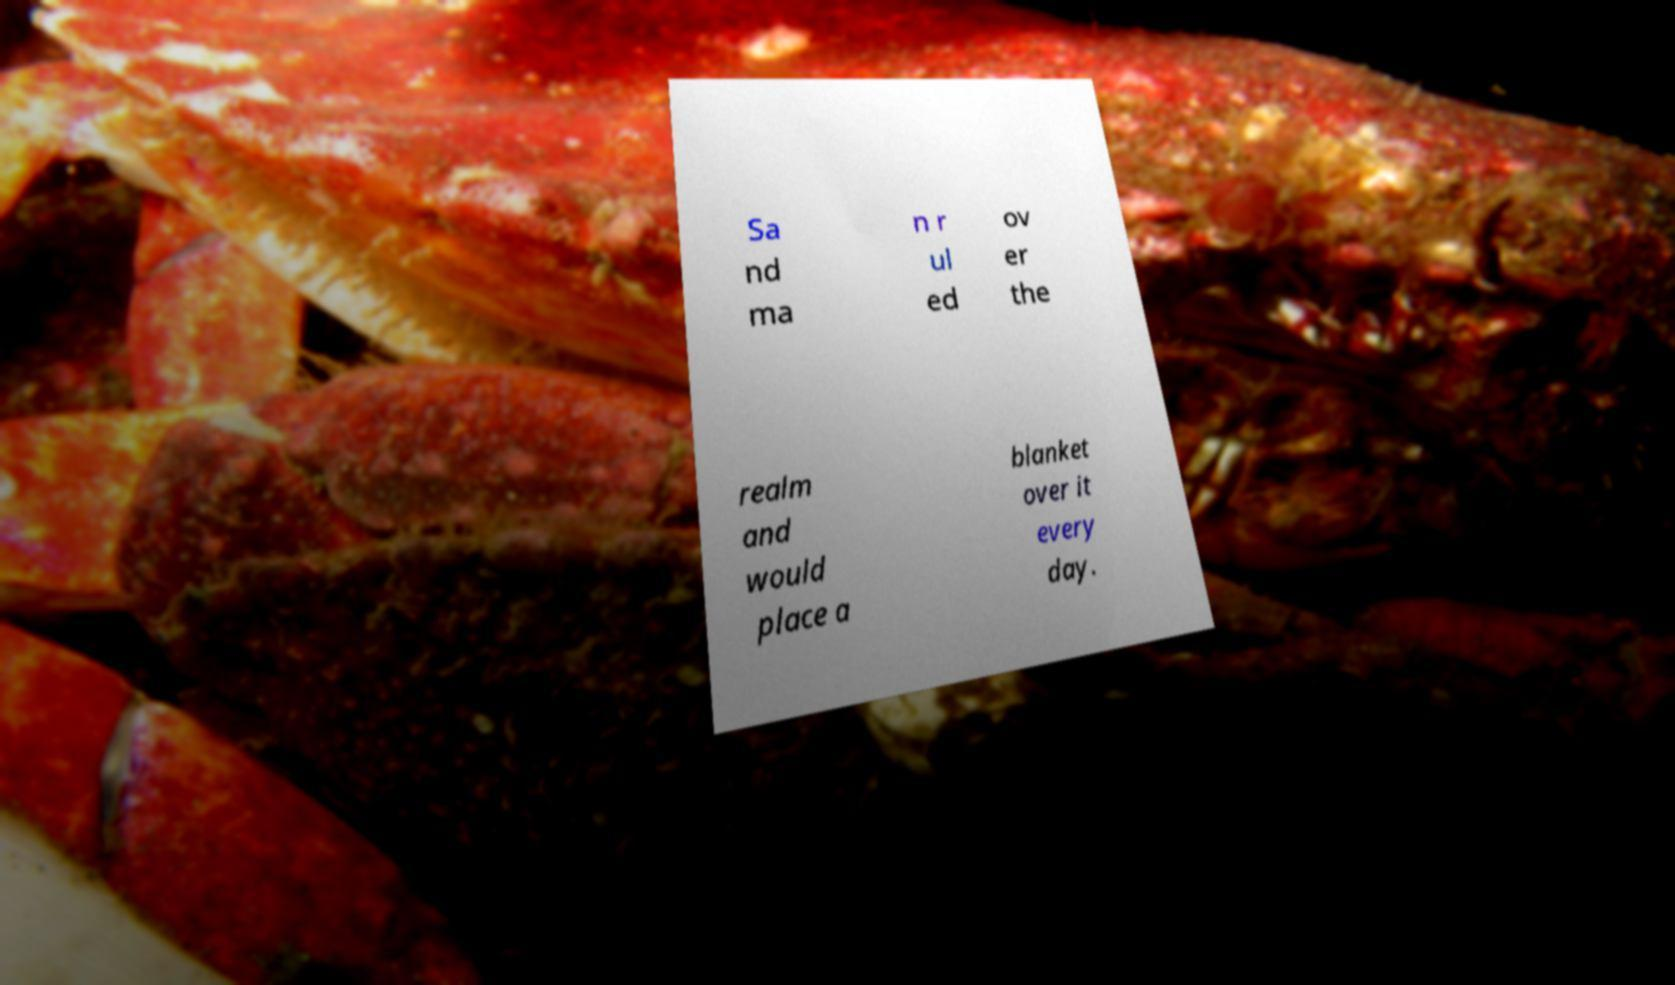For documentation purposes, I need the text within this image transcribed. Could you provide that? Sa nd ma n r ul ed ov er the realm and would place a blanket over it every day. 